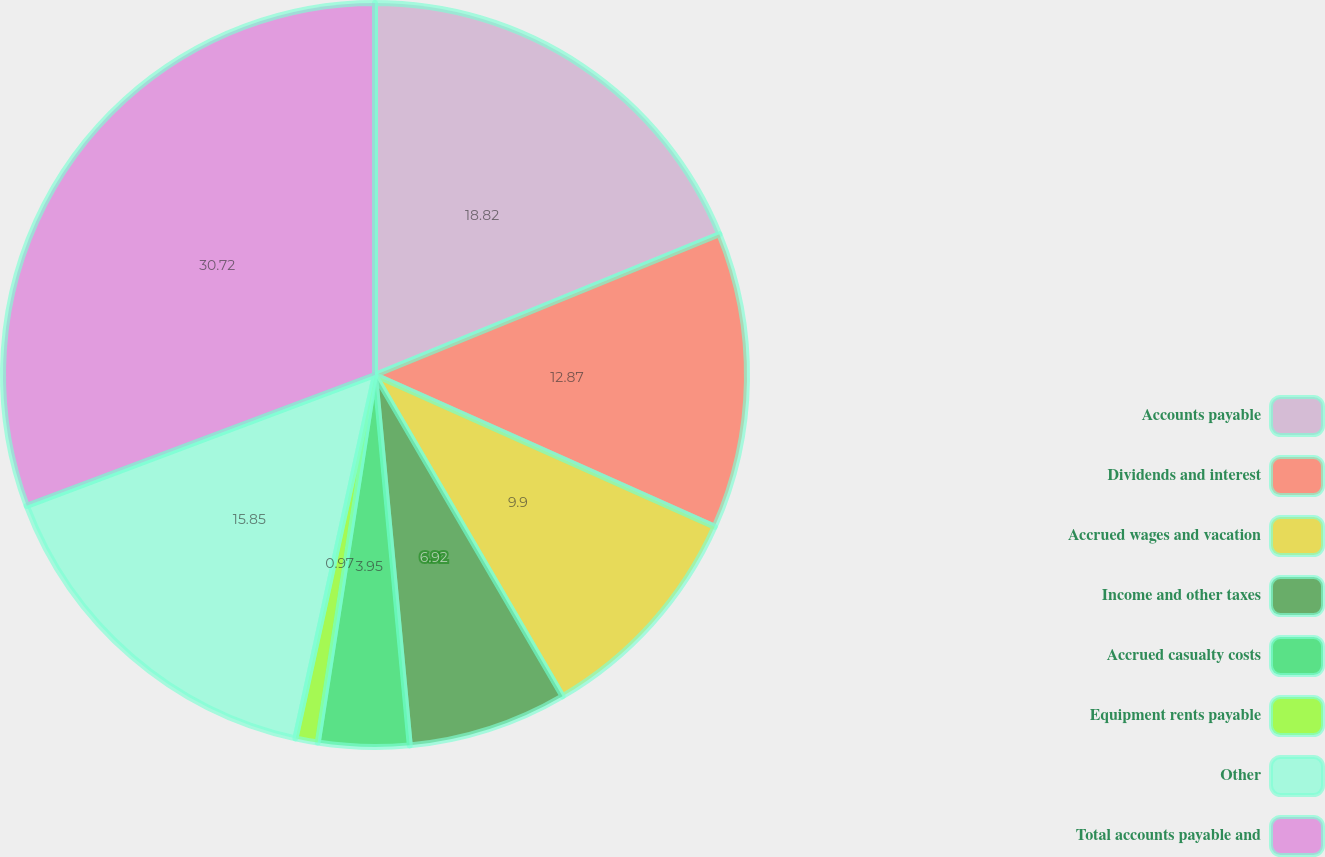<chart> <loc_0><loc_0><loc_500><loc_500><pie_chart><fcel>Accounts payable<fcel>Dividends and interest<fcel>Accrued wages and vacation<fcel>Income and other taxes<fcel>Accrued casualty costs<fcel>Equipment rents payable<fcel>Other<fcel>Total accounts payable and<nl><fcel>18.82%<fcel>12.87%<fcel>9.9%<fcel>6.92%<fcel>3.95%<fcel>0.97%<fcel>15.85%<fcel>30.72%<nl></chart> 